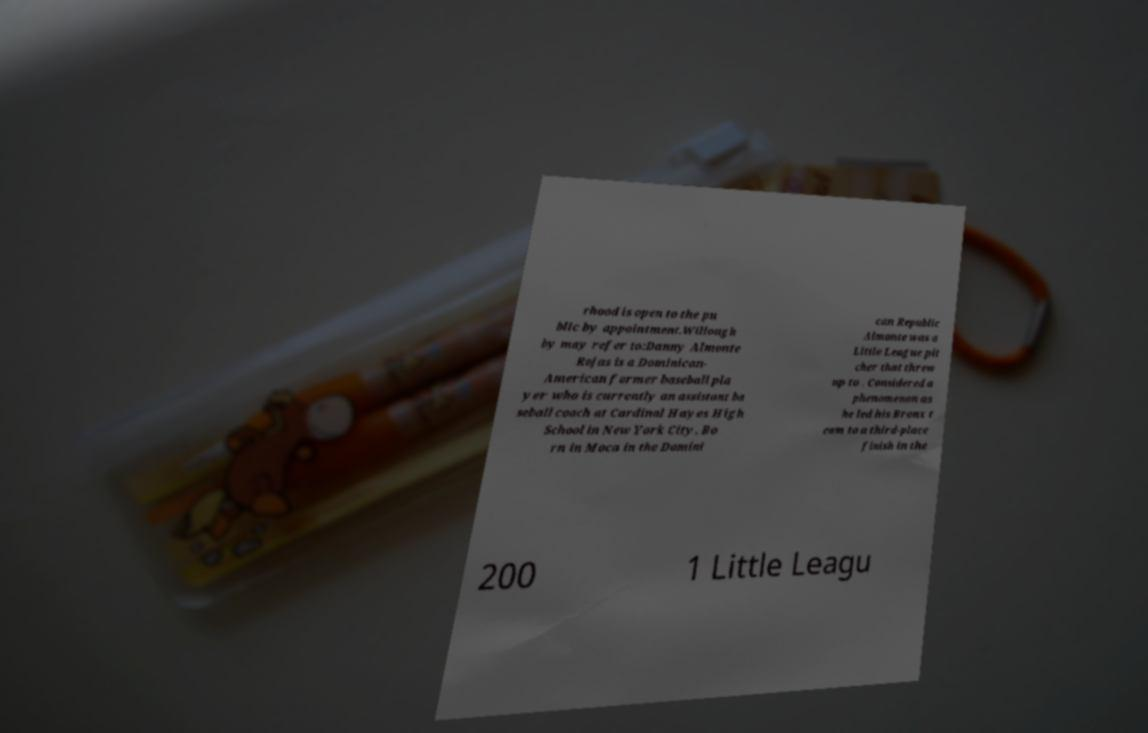I need the written content from this picture converted into text. Can you do that? rhood is open to the pu blic by appointment.Willough by may refer to:Danny Almonte Rojas is a Dominican- American former baseball pla yer who is currently an assistant ba seball coach at Cardinal Hayes High School in New York City. Bo rn in Moca in the Domini can Republic Almonte was a Little League pit cher that threw up to . Considered a phenomenon as he led his Bronx t eam to a third-place finish in the 200 1 Little Leagu 